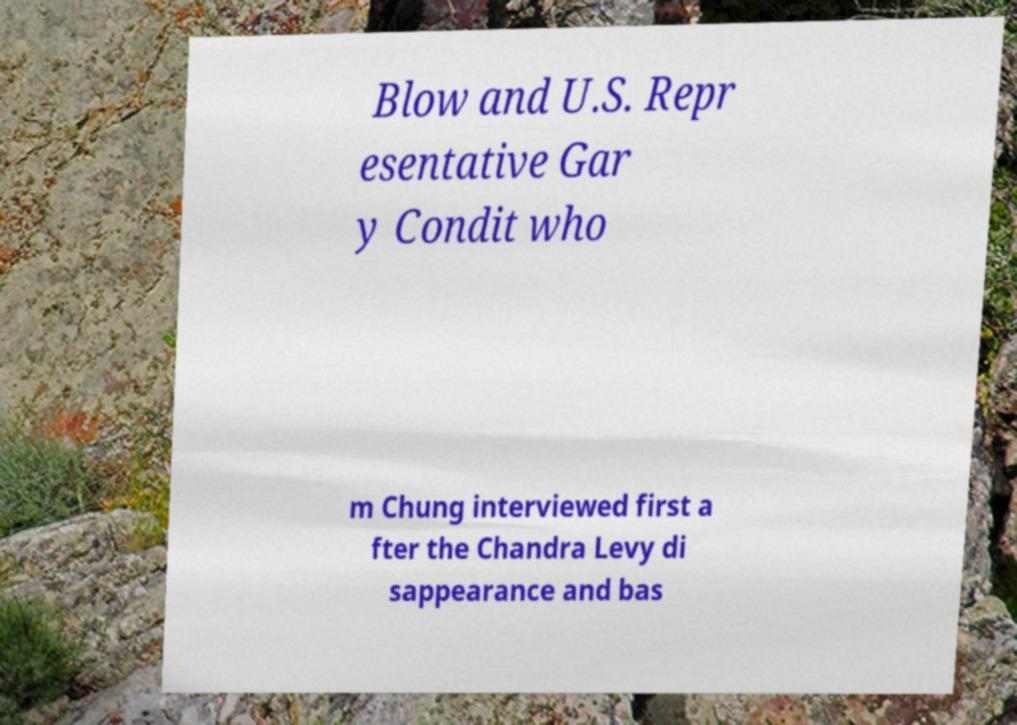Can you read and provide the text displayed in the image?This photo seems to have some interesting text. Can you extract and type it out for me? Blow and U.S. Repr esentative Gar y Condit who m Chung interviewed first a fter the Chandra Levy di sappearance and bas 